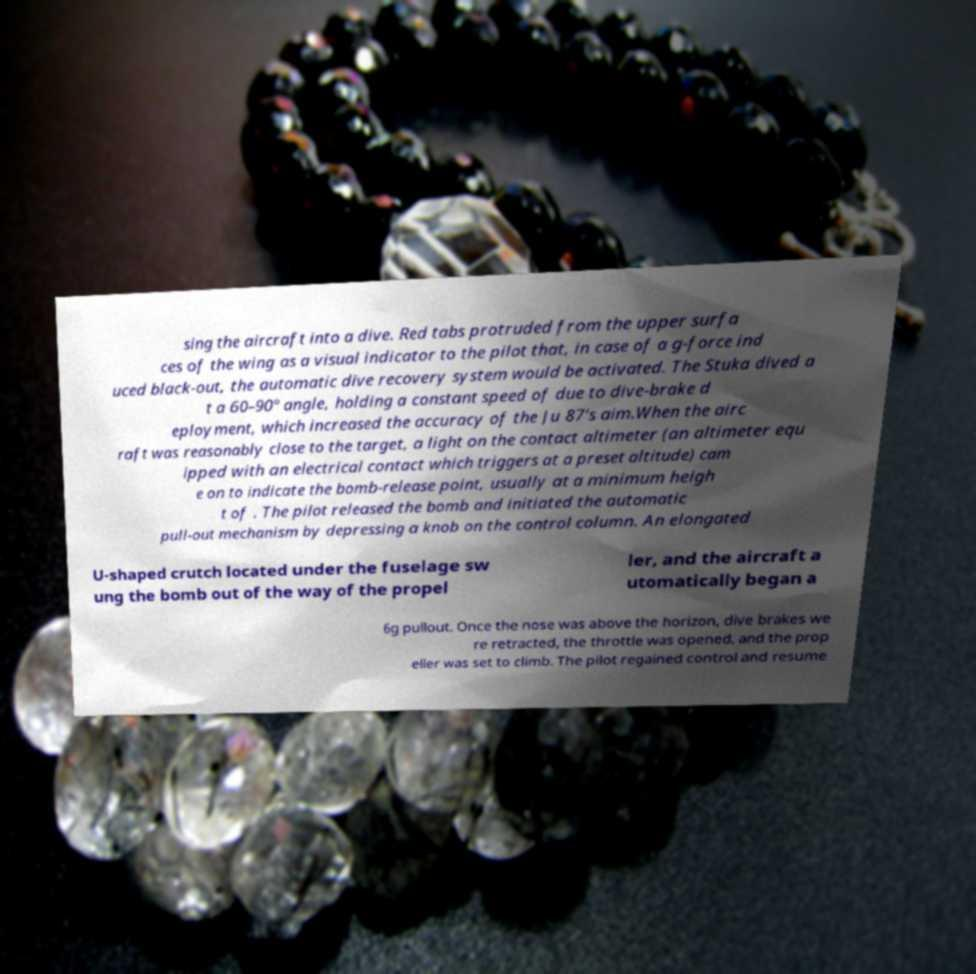Please read and relay the text visible in this image. What does it say? sing the aircraft into a dive. Red tabs protruded from the upper surfa ces of the wing as a visual indicator to the pilot that, in case of a g-force ind uced black-out, the automatic dive recovery system would be activated. The Stuka dived a t a 60–90° angle, holding a constant speed of due to dive-brake d eployment, which increased the accuracy of the Ju 87's aim.When the airc raft was reasonably close to the target, a light on the contact altimeter (an altimeter equ ipped with an electrical contact which triggers at a preset altitude) cam e on to indicate the bomb-release point, usually at a minimum heigh t of . The pilot released the bomb and initiated the automatic pull-out mechanism by depressing a knob on the control column. An elongated U-shaped crutch located under the fuselage sw ung the bomb out of the way of the propel ler, and the aircraft a utomatically began a 6g pullout. Once the nose was above the horizon, dive brakes we re retracted, the throttle was opened, and the prop eller was set to climb. The pilot regained control and resume 